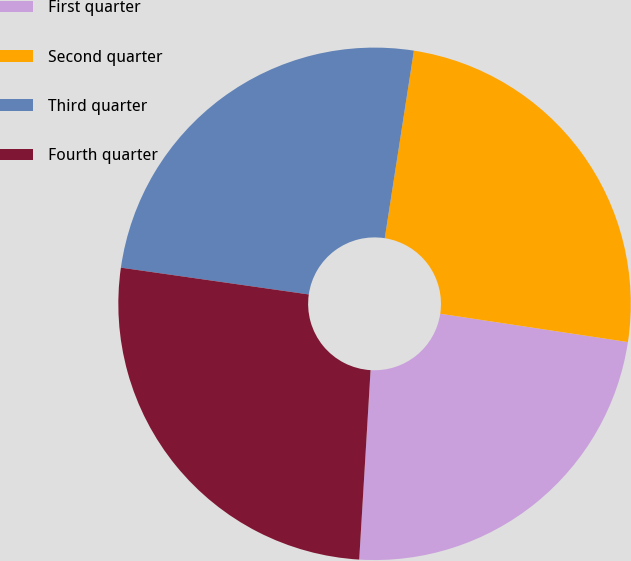<chart> <loc_0><loc_0><loc_500><loc_500><pie_chart><fcel>First quarter<fcel>Second quarter<fcel>Third quarter<fcel>Fourth quarter<nl><fcel>23.57%<fcel>24.93%<fcel>25.2%<fcel>26.3%<nl></chart> 